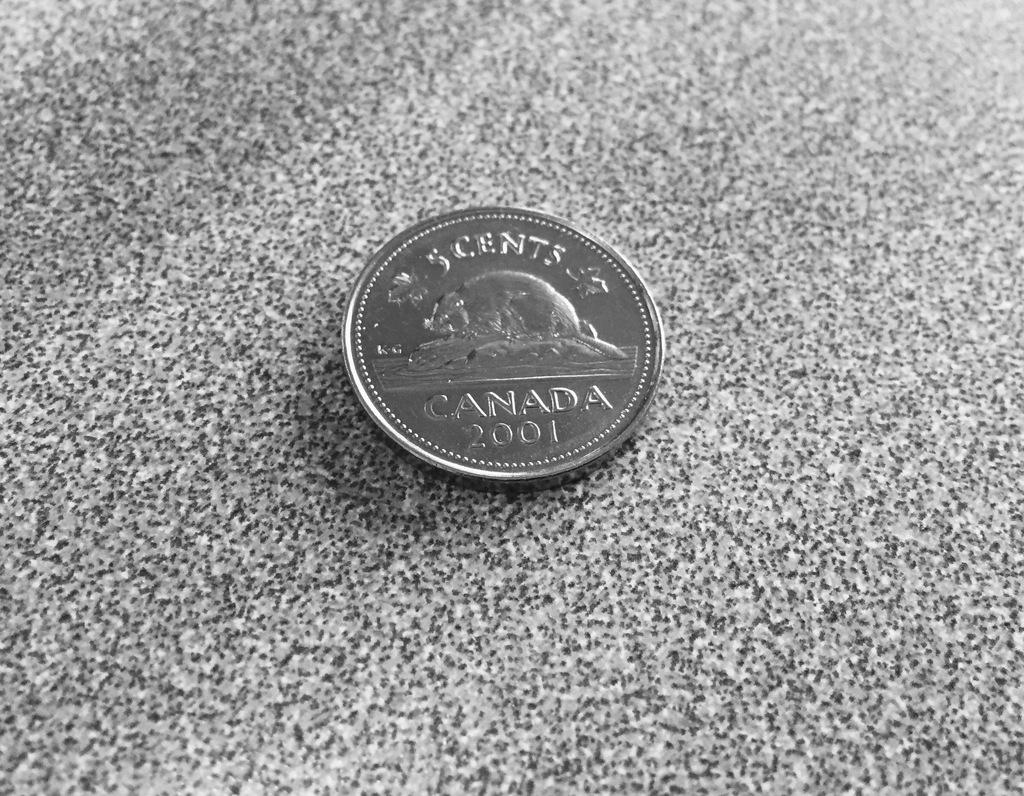What country does the coin mention?
Your answer should be very brief. Canada. How many cents is the coin worth?
Provide a succinct answer. 5. 